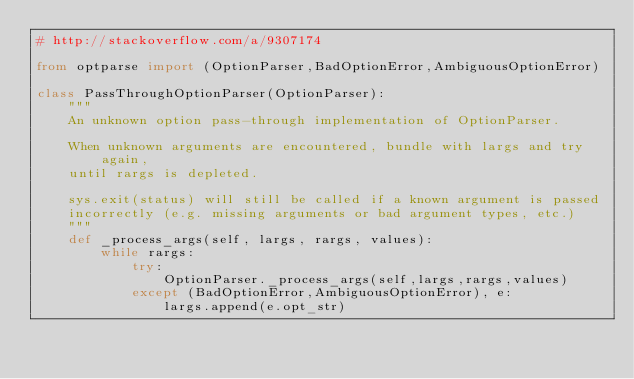Convert code to text. <code><loc_0><loc_0><loc_500><loc_500><_Python_># http://stackoverflow.com/a/9307174

from optparse import (OptionParser,BadOptionError,AmbiguousOptionError)

class PassThroughOptionParser(OptionParser):
    """
    An unknown option pass-through implementation of OptionParser.

    When unknown arguments are encountered, bundle with largs and try again,
    until rargs is depleted.  

    sys.exit(status) will still be called if a known argument is passed
    incorrectly (e.g. missing arguments or bad argument types, etc.)        
    """
    def _process_args(self, largs, rargs, values):
        while rargs:
            try:
                OptionParser._process_args(self,largs,rargs,values)
            except (BadOptionError,AmbiguousOptionError), e:
                largs.append(e.opt_str)
</code> 